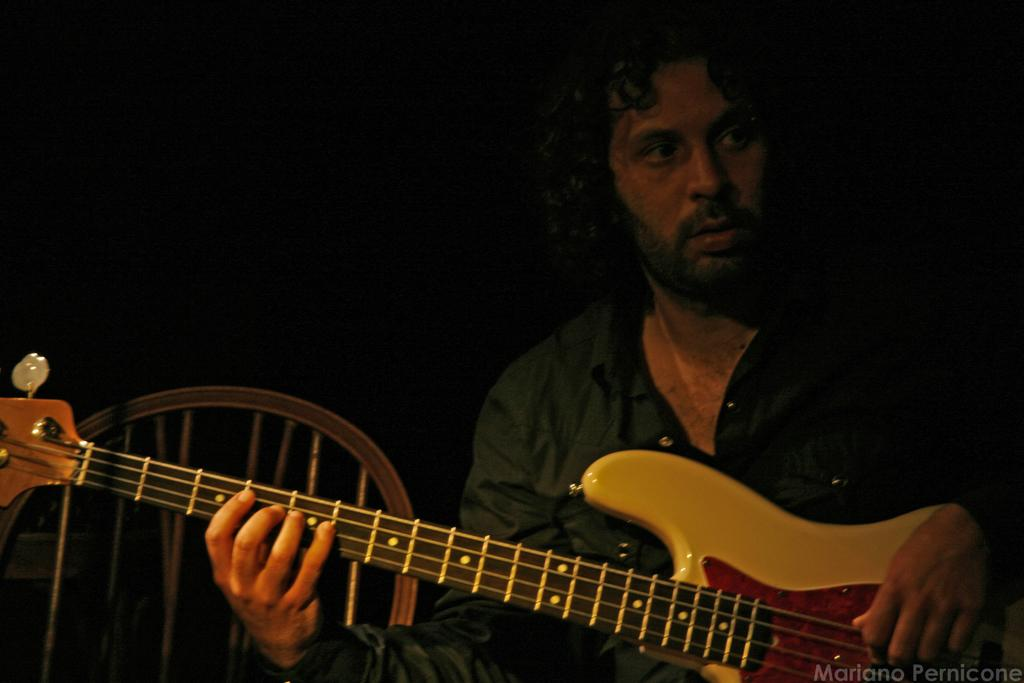Who or what is the main subject in the image? There is a person in the image. What is the person holding in the image? The person is holding a guitar. What piece of furniture is beside the person? There is a chair beside the person. How would you describe the lighting in the image? The background of the image is dark. What type of jar is sitting on the person's finger in the image? There is no jar present on the person's finger in the image. What specific detail can be seen on the guitar in the image? The provided facts do not mention any specific details about the guitar, so we cannot answer this question definitively. 